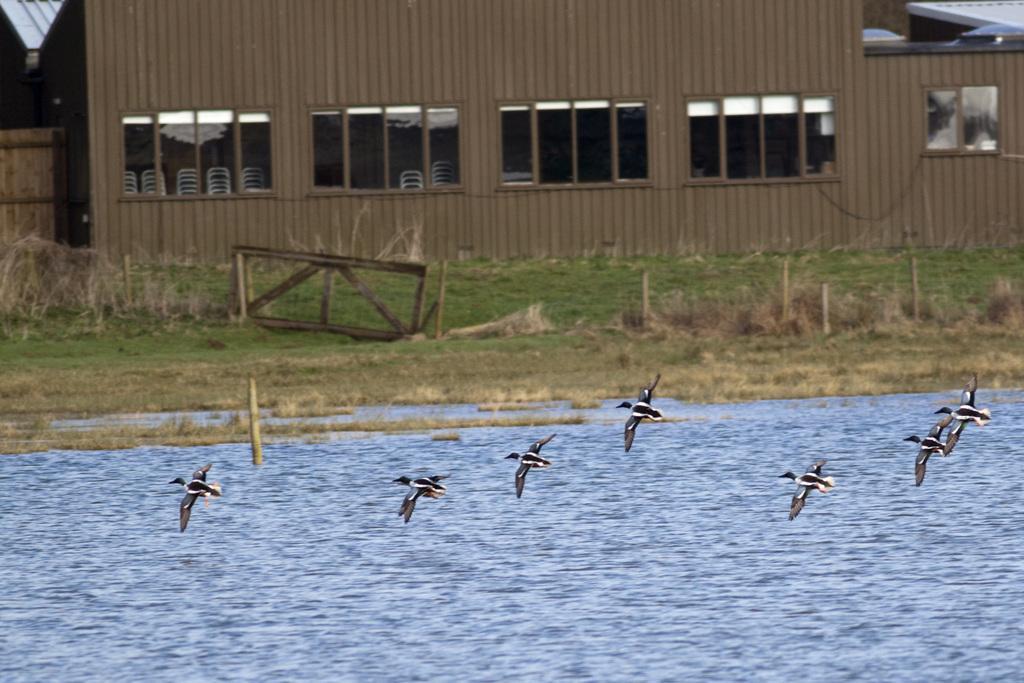Can you describe this image briefly? In the image we can see there are birds flying. We can even see water, grass and the wooden house, and these are the windows. 